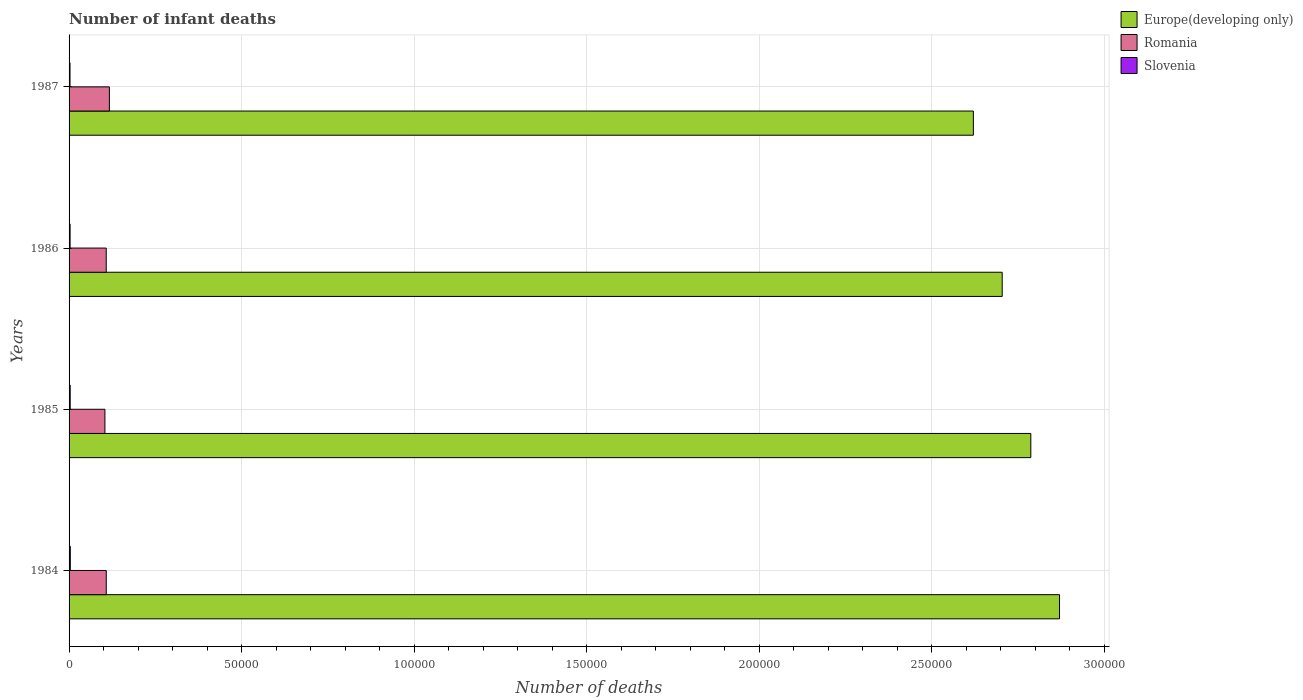How many groups of bars are there?
Provide a succinct answer. 4. Are the number of bars per tick equal to the number of legend labels?
Provide a short and direct response. Yes. Are the number of bars on each tick of the Y-axis equal?
Keep it short and to the point. Yes. What is the label of the 2nd group of bars from the top?
Make the answer very short. 1986. In how many cases, is the number of bars for a given year not equal to the number of legend labels?
Provide a succinct answer. 0. What is the number of infant deaths in Europe(developing only) in 1984?
Your answer should be compact. 2.87e+05. Across all years, what is the maximum number of infant deaths in Europe(developing only)?
Provide a succinct answer. 2.87e+05. Across all years, what is the minimum number of infant deaths in Slovenia?
Provide a succinct answer. 272. In which year was the number of infant deaths in Slovenia maximum?
Your answer should be compact. 1984. What is the total number of infant deaths in Slovenia in the graph?
Ensure brevity in your answer.  1244. What is the difference between the number of infant deaths in Europe(developing only) in 1986 and that in 1987?
Provide a short and direct response. 8356. What is the difference between the number of infant deaths in Slovenia in 1985 and the number of infant deaths in Europe(developing only) in 1984?
Offer a very short reply. -2.87e+05. What is the average number of infant deaths in Europe(developing only) per year?
Your response must be concise. 2.75e+05. In the year 1986, what is the difference between the number of infant deaths in Romania and number of infant deaths in Slovenia?
Ensure brevity in your answer.  1.05e+04. In how many years, is the number of infant deaths in Slovenia greater than 70000 ?
Offer a terse response. 0. What is the ratio of the number of infant deaths in Slovenia in 1985 to that in 1987?
Your answer should be compact. 1.18. Is the number of infant deaths in Europe(developing only) in 1984 less than that in 1987?
Your response must be concise. No. Is the difference between the number of infant deaths in Romania in 1985 and 1987 greater than the difference between the number of infant deaths in Slovenia in 1985 and 1987?
Provide a short and direct response. No. What is the difference between the highest and the lowest number of infant deaths in Europe(developing only)?
Your response must be concise. 2.50e+04. In how many years, is the number of infant deaths in Romania greater than the average number of infant deaths in Romania taken over all years?
Give a very brief answer. 1. What does the 1st bar from the top in 1986 represents?
Your answer should be very brief. Slovenia. What does the 1st bar from the bottom in 1985 represents?
Offer a terse response. Europe(developing only). Is it the case that in every year, the sum of the number of infant deaths in Slovenia and number of infant deaths in Romania is greater than the number of infant deaths in Europe(developing only)?
Keep it short and to the point. No. How many bars are there?
Your response must be concise. 12. Are all the bars in the graph horizontal?
Offer a very short reply. Yes. Are the values on the major ticks of X-axis written in scientific E-notation?
Provide a short and direct response. No. Does the graph contain any zero values?
Keep it short and to the point. No. Does the graph contain grids?
Give a very brief answer. Yes. Where does the legend appear in the graph?
Provide a short and direct response. Top right. How many legend labels are there?
Provide a short and direct response. 3. What is the title of the graph?
Offer a terse response. Number of infant deaths. What is the label or title of the X-axis?
Make the answer very short. Number of deaths. What is the label or title of the Y-axis?
Your response must be concise. Years. What is the Number of deaths of Europe(developing only) in 1984?
Your answer should be very brief. 2.87e+05. What is the Number of deaths of Romania in 1984?
Provide a succinct answer. 1.08e+04. What is the Number of deaths in Slovenia in 1984?
Provide a short and direct response. 355. What is the Number of deaths of Europe(developing only) in 1985?
Offer a terse response. 2.79e+05. What is the Number of deaths in Romania in 1985?
Your answer should be very brief. 1.04e+04. What is the Number of deaths of Slovenia in 1985?
Give a very brief answer. 322. What is the Number of deaths of Europe(developing only) in 1986?
Provide a succinct answer. 2.70e+05. What is the Number of deaths in Romania in 1986?
Make the answer very short. 1.08e+04. What is the Number of deaths in Slovenia in 1986?
Provide a succinct answer. 295. What is the Number of deaths in Europe(developing only) in 1987?
Offer a very short reply. 2.62e+05. What is the Number of deaths in Romania in 1987?
Provide a succinct answer. 1.17e+04. What is the Number of deaths in Slovenia in 1987?
Your answer should be very brief. 272. Across all years, what is the maximum Number of deaths in Europe(developing only)?
Give a very brief answer. 2.87e+05. Across all years, what is the maximum Number of deaths in Romania?
Provide a short and direct response. 1.17e+04. Across all years, what is the maximum Number of deaths of Slovenia?
Provide a succinct answer. 355. Across all years, what is the minimum Number of deaths in Europe(developing only)?
Your response must be concise. 2.62e+05. Across all years, what is the minimum Number of deaths in Romania?
Ensure brevity in your answer.  1.04e+04. Across all years, what is the minimum Number of deaths of Slovenia?
Your answer should be very brief. 272. What is the total Number of deaths of Europe(developing only) in the graph?
Your answer should be compact. 1.10e+06. What is the total Number of deaths in Romania in the graph?
Offer a terse response. 4.36e+04. What is the total Number of deaths in Slovenia in the graph?
Your response must be concise. 1244. What is the difference between the Number of deaths in Europe(developing only) in 1984 and that in 1985?
Your answer should be very brief. 8320. What is the difference between the Number of deaths of Romania in 1984 and that in 1985?
Your answer should be very brief. 396. What is the difference between the Number of deaths of Europe(developing only) in 1984 and that in 1986?
Keep it short and to the point. 1.66e+04. What is the difference between the Number of deaths in Romania in 1984 and that in 1986?
Your answer should be compact. 8. What is the difference between the Number of deaths of Slovenia in 1984 and that in 1986?
Offer a very short reply. 60. What is the difference between the Number of deaths of Europe(developing only) in 1984 and that in 1987?
Offer a very short reply. 2.50e+04. What is the difference between the Number of deaths of Romania in 1984 and that in 1987?
Keep it short and to the point. -907. What is the difference between the Number of deaths of Slovenia in 1984 and that in 1987?
Keep it short and to the point. 83. What is the difference between the Number of deaths in Europe(developing only) in 1985 and that in 1986?
Offer a terse response. 8294. What is the difference between the Number of deaths of Romania in 1985 and that in 1986?
Keep it short and to the point. -388. What is the difference between the Number of deaths in Europe(developing only) in 1985 and that in 1987?
Ensure brevity in your answer.  1.66e+04. What is the difference between the Number of deaths in Romania in 1985 and that in 1987?
Your response must be concise. -1303. What is the difference between the Number of deaths of Europe(developing only) in 1986 and that in 1987?
Ensure brevity in your answer.  8356. What is the difference between the Number of deaths in Romania in 1986 and that in 1987?
Offer a terse response. -915. What is the difference between the Number of deaths of Slovenia in 1986 and that in 1987?
Provide a succinct answer. 23. What is the difference between the Number of deaths in Europe(developing only) in 1984 and the Number of deaths in Romania in 1985?
Your answer should be very brief. 2.77e+05. What is the difference between the Number of deaths of Europe(developing only) in 1984 and the Number of deaths of Slovenia in 1985?
Give a very brief answer. 2.87e+05. What is the difference between the Number of deaths in Romania in 1984 and the Number of deaths in Slovenia in 1985?
Make the answer very short. 1.05e+04. What is the difference between the Number of deaths in Europe(developing only) in 1984 and the Number of deaths in Romania in 1986?
Provide a short and direct response. 2.76e+05. What is the difference between the Number of deaths in Europe(developing only) in 1984 and the Number of deaths in Slovenia in 1986?
Provide a short and direct response. 2.87e+05. What is the difference between the Number of deaths in Romania in 1984 and the Number of deaths in Slovenia in 1986?
Your answer should be compact. 1.05e+04. What is the difference between the Number of deaths of Europe(developing only) in 1984 and the Number of deaths of Romania in 1987?
Provide a short and direct response. 2.75e+05. What is the difference between the Number of deaths of Europe(developing only) in 1984 and the Number of deaths of Slovenia in 1987?
Keep it short and to the point. 2.87e+05. What is the difference between the Number of deaths in Romania in 1984 and the Number of deaths in Slovenia in 1987?
Ensure brevity in your answer.  1.05e+04. What is the difference between the Number of deaths of Europe(developing only) in 1985 and the Number of deaths of Romania in 1986?
Give a very brief answer. 2.68e+05. What is the difference between the Number of deaths of Europe(developing only) in 1985 and the Number of deaths of Slovenia in 1986?
Your answer should be compact. 2.78e+05. What is the difference between the Number of deaths in Romania in 1985 and the Number of deaths in Slovenia in 1986?
Offer a terse response. 1.01e+04. What is the difference between the Number of deaths of Europe(developing only) in 1985 and the Number of deaths of Romania in 1987?
Your answer should be compact. 2.67e+05. What is the difference between the Number of deaths of Europe(developing only) in 1985 and the Number of deaths of Slovenia in 1987?
Your answer should be compact. 2.78e+05. What is the difference between the Number of deaths of Romania in 1985 and the Number of deaths of Slovenia in 1987?
Offer a very short reply. 1.01e+04. What is the difference between the Number of deaths in Europe(developing only) in 1986 and the Number of deaths in Romania in 1987?
Make the answer very short. 2.59e+05. What is the difference between the Number of deaths of Europe(developing only) in 1986 and the Number of deaths of Slovenia in 1987?
Keep it short and to the point. 2.70e+05. What is the difference between the Number of deaths in Romania in 1986 and the Number of deaths in Slovenia in 1987?
Provide a succinct answer. 1.05e+04. What is the average Number of deaths of Europe(developing only) per year?
Offer a very short reply. 2.75e+05. What is the average Number of deaths in Romania per year?
Ensure brevity in your answer.  1.09e+04. What is the average Number of deaths of Slovenia per year?
Keep it short and to the point. 311. In the year 1984, what is the difference between the Number of deaths in Europe(developing only) and Number of deaths in Romania?
Make the answer very short. 2.76e+05. In the year 1984, what is the difference between the Number of deaths of Europe(developing only) and Number of deaths of Slovenia?
Provide a succinct answer. 2.87e+05. In the year 1984, what is the difference between the Number of deaths of Romania and Number of deaths of Slovenia?
Provide a succinct answer. 1.04e+04. In the year 1985, what is the difference between the Number of deaths of Europe(developing only) and Number of deaths of Romania?
Ensure brevity in your answer.  2.68e+05. In the year 1985, what is the difference between the Number of deaths in Europe(developing only) and Number of deaths in Slovenia?
Give a very brief answer. 2.78e+05. In the year 1985, what is the difference between the Number of deaths of Romania and Number of deaths of Slovenia?
Offer a terse response. 1.01e+04. In the year 1986, what is the difference between the Number of deaths in Europe(developing only) and Number of deaths in Romania?
Provide a short and direct response. 2.60e+05. In the year 1986, what is the difference between the Number of deaths of Europe(developing only) and Number of deaths of Slovenia?
Make the answer very short. 2.70e+05. In the year 1986, what is the difference between the Number of deaths of Romania and Number of deaths of Slovenia?
Offer a very short reply. 1.05e+04. In the year 1987, what is the difference between the Number of deaths in Europe(developing only) and Number of deaths in Romania?
Make the answer very short. 2.50e+05. In the year 1987, what is the difference between the Number of deaths in Europe(developing only) and Number of deaths in Slovenia?
Offer a terse response. 2.62e+05. In the year 1987, what is the difference between the Number of deaths of Romania and Number of deaths of Slovenia?
Offer a terse response. 1.14e+04. What is the ratio of the Number of deaths of Europe(developing only) in 1984 to that in 1985?
Provide a short and direct response. 1.03. What is the ratio of the Number of deaths in Romania in 1984 to that in 1985?
Your response must be concise. 1.04. What is the ratio of the Number of deaths in Slovenia in 1984 to that in 1985?
Make the answer very short. 1.1. What is the ratio of the Number of deaths of Europe(developing only) in 1984 to that in 1986?
Provide a succinct answer. 1.06. What is the ratio of the Number of deaths of Slovenia in 1984 to that in 1986?
Keep it short and to the point. 1.2. What is the ratio of the Number of deaths in Europe(developing only) in 1984 to that in 1987?
Your answer should be compact. 1.1. What is the ratio of the Number of deaths of Romania in 1984 to that in 1987?
Your answer should be compact. 0.92. What is the ratio of the Number of deaths of Slovenia in 1984 to that in 1987?
Ensure brevity in your answer.  1.31. What is the ratio of the Number of deaths of Europe(developing only) in 1985 to that in 1986?
Offer a very short reply. 1.03. What is the ratio of the Number of deaths of Slovenia in 1985 to that in 1986?
Ensure brevity in your answer.  1.09. What is the ratio of the Number of deaths of Europe(developing only) in 1985 to that in 1987?
Your response must be concise. 1.06. What is the ratio of the Number of deaths of Romania in 1985 to that in 1987?
Offer a terse response. 0.89. What is the ratio of the Number of deaths in Slovenia in 1985 to that in 1987?
Ensure brevity in your answer.  1.18. What is the ratio of the Number of deaths of Europe(developing only) in 1986 to that in 1987?
Offer a terse response. 1.03. What is the ratio of the Number of deaths of Romania in 1986 to that in 1987?
Keep it short and to the point. 0.92. What is the ratio of the Number of deaths of Slovenia in 1986 to that in 1987?
Ensure brevity in your answer.  1.08. What is the difference between the highest and the second highest Number of deaths in Europe(developing only)?
Provide a succinct answer. 8320. What is the difference between the highest and the second highest Number of deaths of Romania?
Offer a terse response. 907. What is the difference between the highest and the lowest Number of deaths in Europe(developing only)?
Your answer should be compact. 2.50e+04. What is the difference between the highest and the lowest Number of deaths of Romania?
Your answer should be compact. 1303. What is the difference between the highest and the lowest Number of deaths in Slovenia?
Ensure brevity in your answer.  83. 